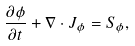Convert formula to latex. <formula><loc_0><loc_0><loc_500><loc_500>\frac { \partial \phi } { \partial t } + \nabla \cdot J _ { \phi } = S _ { \phi } ,</formula> 